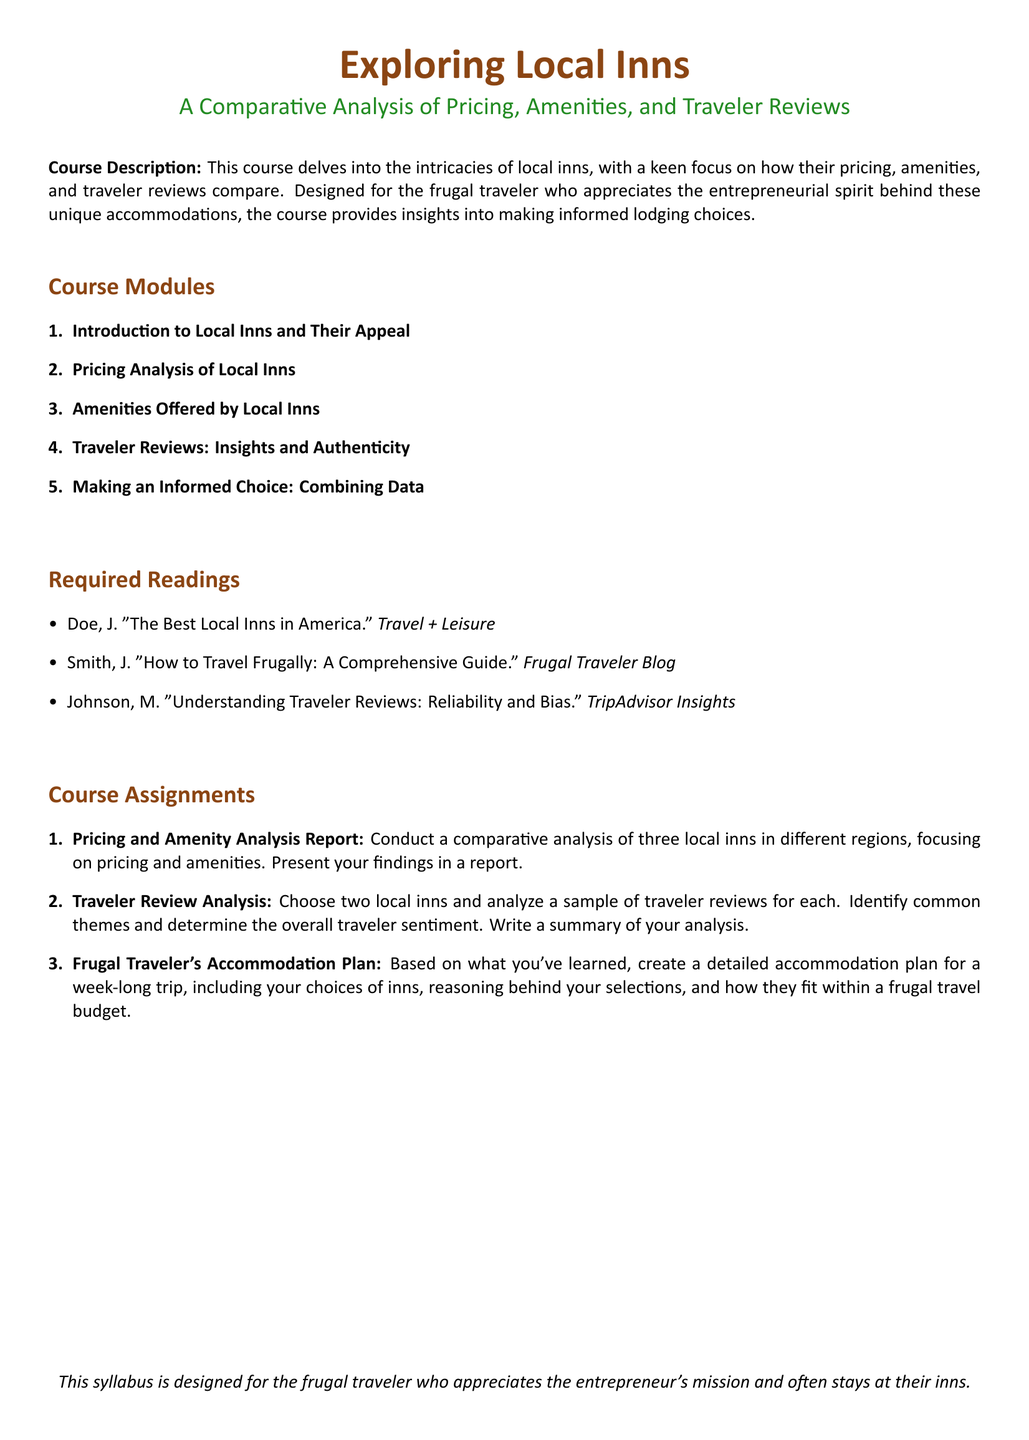What is the title of the course? The title of the course is the main heading of the document, which expresses the focus on local inns and traveler experiences.
Answer: Exploring Local Inns How many modules are there in the course? The total number of modules is the count listed under the course modules section.
Answer: Five What is the focus of the course? The focus of the course can be summarized by the phrase that describes the comparative analysis within the document.
Answer: Pricing, Amenities, and Traveler Reviews Who is the target audience for this course? The target audience is described in a specific phrase that highlights their characteristics and preferences in the document.
Answer: Frugal traveler What type of report is required as an assignment? The required report is specified as a type of assignment under course assignments, detailing its focus.
Answer: Pricing and Amenity Analysis Report What is the purpose of traveler review analysis? The purpose is to examine traveler sentiments and themes, which can be inferred from the assignment's description.
Answer: Analyze a sample of traveler reviews Which reading discusses reliability and bias in traveler reviews? The required reading specifically addressing this topic is identified by the author's last name and the title of the work.
Answer: Johnson, M. "Understanding Traveler Reviews: Reliability and Bias." 